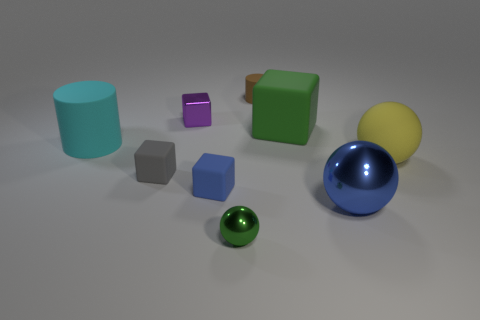What kind of mood or theme does the arrangement of these objects convey? The image's composition, featuring simplistic geometric shapes in bold and varying colors against a plain background, conveys a sense of minimalism and modernity. The carefully spaced arrangement of the objects and their diverse colors and materials may be seen as a nod to contemporary art, invoking a theme of organized variety. The setting does not seem to simulate any real-world scene but rather projects an abstract and tranquil mood, where each object can be appreciated for its individual characteristics. 